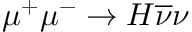<formula> <loc_0><loc_0><loc_500><loc_500>\mu ^ { + } \mu ^ { - } \to H \overline { \nu } \nu</formula> 